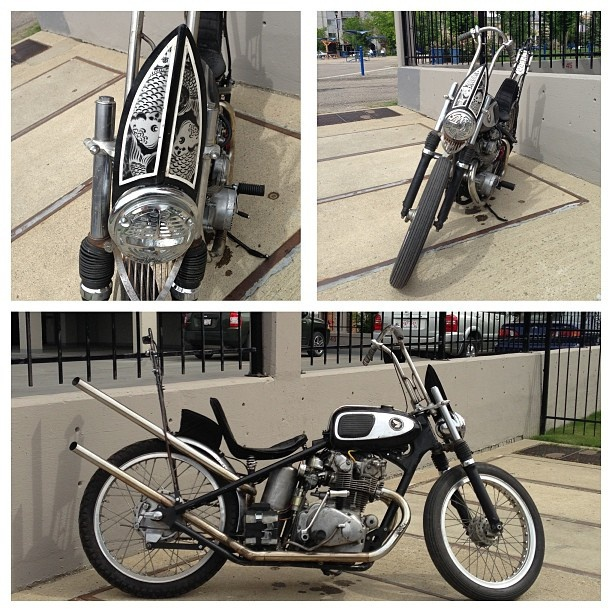Describe the objects in this image and their specific colors. I can see motorcycle in white, black, gray, and darkgray tones, motorcycle in white, black, gray, and darkgray tones, motorcycle in white, black, gray, lightgray, and darkgray tones, car in white, black, gray, darkgray, and lightgray tones, and car in white, black, gray, darkgray, and maroon tones in this image. 